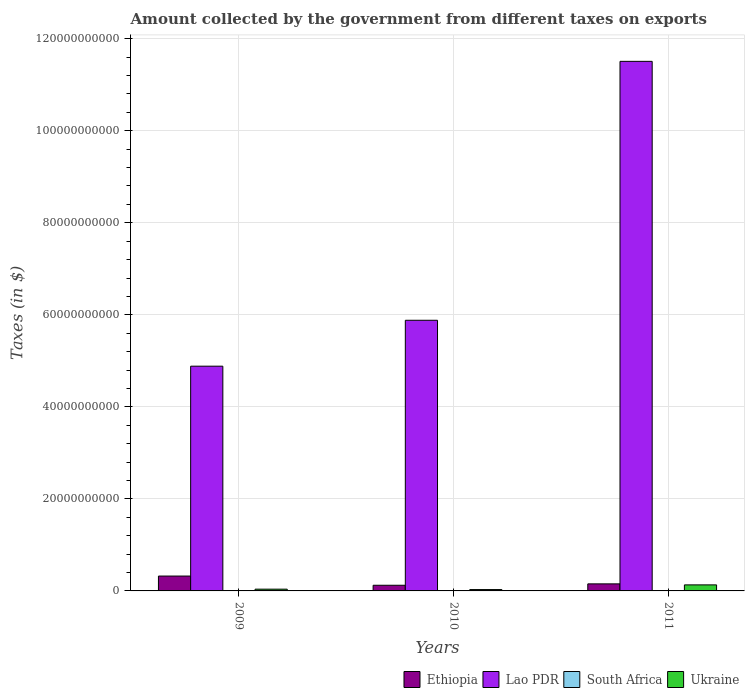How many groups of bars are there?
Your answer should be compact. 3. Are the number of bars on each tick of the X-axis equal?
Provide a short and direct response. Yes. What is the label of the 3rd group of bars from the left?
Your answer should be compact. 2011. In how many cases, is the number of bars for a given year not equal to the number of legend labels?
Make the answer very short. 0. What is the amount collected by the government from taxes on exports in Ethiopia in 2009?
Ensure brevity in your answer.  3.23e+09. Across all years, what is the maximum amount collected by the government from taxes on exports in Ethiopia?
Make the answer very short. 3.23e+09. Across all years, what is the minimum amount collected by the government from taxes on exports in Ethiopia?
Make the answer very short. 1.23e+09. In which year was the amount collected by the government from taxes on exports in Lao PDR minimum?
Your answer should be very brief. 2009. What is the total amount collected by the government from taxes on exports in Ethiopia in the graph?
Offer a terse response. 5.99e+09. What is the difference between the amount collected by the government from taxes on exports in Ethiopia in 2009 and that in 2011?
Ensure brevity in your answer.  1.70e+09. What is the difference between the amount collected by the government from taxes on exports in Ethiopia in 2011 and the amount collected by the government from taxes on exports in Lao PDR in 2009?
Make the answer very short. -4.73e+1. What is the average amount collected by the government from taxes on exports in South Africa per year?
Give a very brief answer. 5.69e+07. In the year 2011, what is the difference between the amount collected by the government from taxes on exports in Lao PDR and amount collected by the government from taxes on exports in South Africa?
Offer a very short reply. 1.15e+11. In how many years, is the amount collected by the government from taxes on exports in South Africa greater than 32000000000 $?
Your response must be concise. 0. What is the ratio of the amount collected by the government from taxes on exports in Lao PDR in 2009 to that in 2010?
Make the answer very short. 0.83. Is the amount collected by the government from taxes on exports in Lao PDR in 2009 less than that in 2011?
Your response must be concise. Yes. Is the difference between the amount collected by the government from taxes on exports in Lao PDR in 2009 and 2011 greater than the difference between the amount collected by the government from taxes on exports in South Africa in 2009 and 2011?
Offer a very short reply. No. What is the difference between the highest and the second highest amount collected by the government from taxes on exports in Ethiopia?
Your answer should be compact. 1.70e+09. What is the difference between the highest and the lowest amount collected by the government from taxes on exports in Ethiopia?
Your answer should be very brief. 2.00e+09. Is the sum of the amount collected by the government from taxes on exports in Ethiopia in 2010 and 2011 greater than the maximum amount collected by the government from taxes on exports in Ukraine across all years?
Your response must be concise. Yes. Is it the case that in every year, the sum of the amount collected by the government from taxes on exports in South Africa and amount collected by the government from taxes on exports in Ukraine is greater than the sum of amount collected by the government from taxes on exports in Ethiopia and amount collected by the government from taxes on exports in Lao PDR?
Offer a very short reply. Yes. What does the 4th bar from the left in 2010 represents?
Offer a terse response. Ukraine. What does the 3rd bar from the right in 2009 represents?
Offer a terse response. Lao PDR. How many bars are there?
Offer a terse response. 12. How many years are there in the graph?
Ensure brevity in your answer.  3. What is the difference between two consecutive major ticks on the Y-axis?
Provide a short and direct response. 2.00e+1. Are the values on the major ticks of Y-axis written in scientific E-notation?
Offer a terse response. No. Does the graph contain grids?
Provide a short and direct response. Yes. How are the legend labels stacked?
Keep it short and to the point. Horizontal. What is the title of the graph?
Make the answer very short. Amount collected by the government from different taxes on exports. What is the label or title of the Y-axis?
Provide a succinct answer. Taxes (in $). What is the Taxes (in $) in Ethiopia in 2009?
Make the answer very short. 3.23e+09. What is the Taxes (in $) of Lao PDR in 2009?
Give a very brief answer. 4.88e+1. What is the Taxes (in $) in South Africa in 2009?
Offer a very short reply. 3.60e+07. What is the Taxes (in $) of Ukraine in 2009?
Keep it short and to the point. 3.83e+08. What is the Taxes (in $) in Ethiopia in 2010?
Offer a very short reply. 1.23e+09. What is the Taxes (in $) in Lao PDR in 2010?
Ensure brevity in your answer.  5.88e+1. What is the Taxes (in $) of South Africa in 2010?
Your response must be concise. 7.04e+07. What is the Taxes (in $) in Ukraine in 2010?
Ensure brevity in your answer.  2.95e+08. What is the Taxes (in $) in Ethiopia in 2011?
Offer a very short reply. 1.53e+09. What is the Taxes (in $) in Lao PDR in 2011?
Provide a succinct answer. 1.15e+11. What is the Taxes (in $) of South Africa in 2011?
Provide a succinct answer. 6.42e+07. What is the Taxes (in $) in Ukraine in 2011?
Keep it short and to the point. 1.31e+09. Across all years, what is the maximum Taxes (in $) of Ethiopia?
Offer a terse response. 3.23e+09. Across all years, what is the maximum Taxes (in $) of Lao PDR?
Provide a succinct answer. 1.15e+11. Across all years, what is the maximum Taxes (in $) of South Africa?
Your response must be concise. 7.04e+07. Across all years, what is the maximum Taxes (in $) of Ukraine?
Keep it short and to the point. 1.31e+09. Across all years, what is the minimum Taxes (in $) in Ethiopia?
Give a very brief answer. 1.23e+09. Across all years, what is the minimum Taxes (in $) in Lao PDR?
Provide a succinct answer. 4.88e+1. Across all years, what is the minimum Taxes (in $) in South Africa?
Your answer should be very brief. 3.60e+07. Across all years, what is the minimum Taxes (in $) of Ukraine?
Offer a terse response. 2.95e+08. What is the total Taxes (in $) of Ethiopia in the graph?
Make the answer very short. 5.99e+09. What is the total Taxes (in $) of Lao PDR in the graph?
Your answer should be compact. 2.23e+11. What is the total Taxes (in $) of South Africa in the graph?
Provide a short and direct response. 1.71e+08. What is the total Taxes (in $) in Ukraine in the graph?
Give a very brief answer. 1.99e+09. What is the difference between the Taxes (in $) in Ethiopia in 2009 and that in 2010?
Provide a short and direct response. 2.00e+09. What is the difference between the Taxes (in $) of Lao PDR in 2009 and that in 2010?
Keep it short and to the point. -9.98e+09. What is the difference between the Taxes (in $) of South Africa in 2009 and that in 2010?
Your response must be concise. -3.44e+07. What is the difference between the Taxes (in $) of Ukraine in 2009 and that in 2010?
Your answer should be very brief. 8.79e+07. What is the difference between the Taxes (in $) of Ethiopia in 2009 and that in 2011?
Provide a short and direct response. 1.70e+09. What is the difference between the Taxes (in $) in Lao PDR in 2009 and that in 2011?
Provide a succinct answer. -6.62e+1. What is the difference between the Taxes (in $) of South Africa in 2009 and that in 2011?
Provide a succinct answer. -2.82e+07. What is the difference between the Taxes (in $) of Ukraine in 2009 and that in 2011?
Your answer should be very brief. -9.29e+08. What is the difference between the Taxes (in $) in Ethiopia in 2010 and that in 2011?
Keep it short and to the point. -3.03e+08. What is the difference between the Taxes (in $) in Lao PDR in 2010 and that in 2011?
Make the answer very short. -5.63e+1. What is the difference between the Taxes (in $) in South Africa in 2010 and that in 2011?
Keep it short and to the point. 6.16e+06. What is the difference between the Taxes (in $) in Ukraine in 2010 and that in 2011?
Provide a short and direct response. -1.02e+09. What is the difference between the Taxes (in $) in Ethiopia in 2009 and the Taxes (in $) in Lao PDR in 2010?
Ensure brevity in your answer.  -5.56e+1. What is the difference between the Taxes (in $) in Ethiopia in 2009 and the Taxes (in $) in South Africa in 2010?
Keep it short and to the point. 3.16e+09. What is the difference between the Taxes (in $) in Ethiopia in 2009 and the Taxes (in $) in Ukraine in 2010?
Offer a very short reply. 2.94e+09. What is the difference between the Taxes (in $) of Lao PDR in 2009 and the Taxes (in $) of South Africa in 2010?
Your answer should be compact. 4.88e+1. What is the difference between the Taxes (in $) in Lao PDR in 2009 and the Taxes (in $) in Ukraine in 2010?
Make the answer very short. 4.85e+1. What is the difference between the Taxes (in $) in South Africa in 2009 and the Taxes (in $) in Ukraine in 2010?
Offer a terse response. -2.59e+08. What is the difference between the Taxes (in $) of Ethiopia in 2009 and the Taxes (in $) of Lao PDR in 2011?
Your answer should be compact. -1.12e+11. What is the difference between the Taxes (in $) of Ethiopia in 2009 and the Taxes (in $) of South Africa in 2011?
Your response must be concise. 3.17e+09. What is the difference between the Taxes (in $) of Ethiopia in 2009 and the Taxes (in $) of Ukraine in 2011?
Your answer should be very brief. 1.92e+09. What is the difference between the Taxes (in $) of Lao PDR in 2009 and the Taxes (in $) of South Africa in 2011?
Offer a terse response. 4.88e+1. What is the difference between the Taxes (in $) in Lao PDR in 2009 and the Taxes (in $) in Ukraine in 2011?
Make the answer very short. 4.75e+1. What is the difference between the Taxes (in $) in South Africa in 2009 and the Taxes (in $) in Ukraine in 2011?
Keep it short and to the point. -1.28e+09. What is the difference between the Taxes (in $) in Ethiopia in 2010 and the Taxes (in $) in Lao PDR in 2011?
Your answer should be compact. -1.14e+11. What is the difference between the Taxes (in $) in Ethiopia in 2010 and the Taxes (in $) in South Africa in 2011?
Your answer should be compact. 1.17e+09. What is the difference between the Taxes (in $) of Ethiopia in 2010 and the Taxes (in $) of Ukraine in 2011?
Provide a short and direct response. -8.16e+07. What is the difference between the Taxes (in $) of Lao PDR in 2010 and the Taxes (in $) of South Africa in 2011?
Make the answer very short. 5.87e+1. What is the difference between the Taxes (in $) in Lao PDR in 2010 and the Taxes (in $) in Ukraine in 2011?
Your answer should be very brief. 5.75e+1. What is the difference between the Taxes (in $) of South Africa in 2010 and the Taxes (in $) of Ukraine in 2011?
Make the answer very short. -1.24e+09. What is the average Taxes (in $) in Ethiopia per year?
Offer a terse response. 2.00e+09. What is the average Taxes (in $) of Lao PDR per year?
Give a very brief answer. 7.42e+1. What is the average Taxes (in $) in South Africa per year?
Offer a terse response. 5.69e+07. What is the average Taxes (in $) in Ukraine per year?
Provide a short and direct response. 6.63e+08. In the year 2009, what is the difference between the Taxes (in $) in Ethiopia and Taxes (in $) in Lao PDR?
Offer a very short reply. -4.56e+1. In the year 2009, what is the difference between the Taxes (in $) in Ethiopia and Taxes (in $) in South Africa?
Provide a succinct answer. 3.19e+09. In the year 2009, what is the difference between the Taxes (in $) of Ethiopia and Taxes (in $) of Ukraine?
Ensure brevity in your answer.  2.85e+09. In the year 2009, what is the difference between the Taxes (in $) in Lao PDR and Taxes (in $) in South Africa?
Offer a very short reply. 4.88e+1. In the year 2009, what is the difference between the Taxes (in $) of Lao PDR and Taxes (in $) of Ukraine?
Provide a short and direct response. 4.85e+1. In the year 2009, what is the difference between the Taxes (in $) in South Africa and Taxes (in $) in Ukraine?
Ensure brevity in your answer.  -3.47e+08. In the year 2010, what is the difference between the Taxes (in $) in Ethiopia and Taxes (in $) in Lao PDR?
Keep it short and to the point. -5.76e+1. In the year 2010, what is the difference between the Taxes (in $) in Ethiopia and Taxes (in $) in South Africa?
Your answer should be very brief. 1.16e+09. In the year 2010, what is the difference between the Taxes (in $) in Ethiopia and Taxes (in $) in Ukraine?
Provide a short and direct response. 9.35e+08. In the year 2010, what is the difference between the Taxes (in $) of Lao PDR and Taxes (in $) of South Africa?
Your response must be concise. 5.87e+1. In the year 2010, what is the difference between the Taxes (in $) of Lao PDR and Taxes (in $) of Ukraine?
Offer a terse response. 5.85e+1. In the year 2010, what is the difference between the Taxes (in $) in South Africa and Taxes (in $) in Ukraine?
Offer a terse response. -2.24e+08. In the year 2011, what is the difference between the Taxes (in $) of Ethiopia and Taxes (in $) of Lao PDR?
Keep it short and to the point. -1.14e+11. In the year 2011, what is the difference between the Taxes (in $) in Ethiopia and Taxes (in $) in South Africa?
Provide a succinct answer. 1.47e+09. In the year 2011, what is the difference between the Taxes (in $) in Ethiopia and Taxes (in $) in Ukraine?
Your answer should be compact. 2.21e+08. In the year 2011, what is the difference between the Taxes (in $) in Lao PDR and Taxes (in $) in South Africa?
Make the answer very short. 1.15e+11. In the year 2011, what is the difference between the Taxes (in $) of Lao PDR and Taxes (in $) of Ukraine?
Offer a terse response. 1.14e+11. In the year 2011, what is the difference between the Taxes (in $) in South Africa and Taxes (in $) in Ukraine?
Keep it short and to the point. -1.25e+09. What is the ratio of the Taxes (in $) of Ethiopia in 2009 to that in 2010?
Your response must be concise. 2.63. What is the ratio of the Taxes (in $) in Lao PDR in 2009 to that in 2010?
Offer a terse response. 0.83. What is the ratio of the Taxes (in $) of South Africa in 2009 to that in 2010?
Ensure brevity in your answer.  0.51. What is the ratio of the Taxes (in $) of Ukraine in 2009 to that in 2010?
Offer a terse response. 1.3. What is the ratio of the Taxes (in $) of Ethiopia in 2009 to that in 2011?
Your answer should be compact. 2.11. What is the ratio of the Taxes (in $) of Lao PDR in 2009 to that in 2011?
Provide a short and direct response. 0.42. What is the ratio of the Taxes (in $) of South Africa in 2009 to that in 2011?
Your response must be concise. 0.56. What is the ratio of the Taxes (in $) in Ukraine in 2009 to that in 2011?
Offer a terse response. 0.29. What is the ratio of the Taxes (in $) in Ethiopia in 2010 to that in 2011?
Your answer should be compact. 0.8. What is the ratio of the Taxes (in $) in Lao PDR in 2010 to that in 2011?
Make the answer very short. 0.51. What is the ratio of the Taxes (in $) in South Africa in 2010 to that in 2011?
Make the answer very short. 1.1. What is the ratio of the Taxes (in $) of Ukraine in 2010 to that in 2011?
Offer a very short reply. 0.22. What is the difference between the highest and the second highest Taxes (in $) of Ethiopia?
Make the answer very short. 1.70e+09. What is the difference between the highest and the second highest Taxes (in $) of Lao PDR?
Ensure brevity in your answer.  5.63e+1. What is the difference between the highest and the second highest Taxes (in $) of South Africa?
Your response must be concise. 6.16e+06. What is the difference between the highest and the second highest Taxes (in $) in Ukraine?
Your answer should be compact. 9.29e+08. What is the difference between the highest and the lowest Taxes (in $) of Ethiopia?
Ensure brevity in your answer.  2.00e+09. What is the difference between the highest and the lowest Taxes (in $) of Lao PDR?
Ensure brevity in your answer.  6.62e+1. What is the difference between the highest and the lowest Taxes (in $) of South Africa?
Your response must be concise. 3.44e+07. What is the difference between the highest and the lowest Taxes (in $) in Ukraine?
Provide a short and direct response. 1.02e+09. 